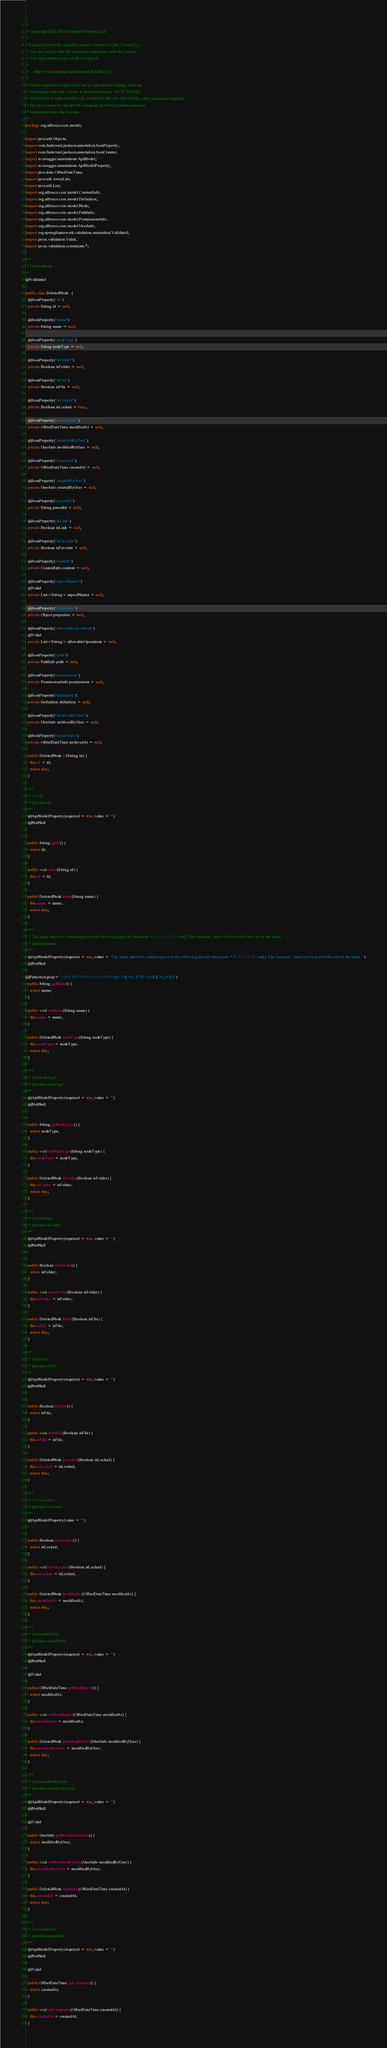<code> <loc_0><loc_0><loc_500><loc_500><_Java_>/*
 * Copyright 2021-2021 Alfresco Software, Ltd.
 *
 * Licensed under the Apache License, Version 2.0 (the "License");
 * you may not use this file except in compliance with the License.
 * You may obtain a copy of the License at
 *
 *     http://www.apache.org/licenses/LICENSE-2.0
 *
 * Unless required by applicable law or agreed to in writing, software
 * distributed under the License is distributed on an "AS IS" BASIS,
 * WITHOUT WARRANTIES OR CONDITIONS OF ANY KIND, either express or implied.
 * See the License for the specific language governing permissions and
 * limitations under the License.
 */
package org.alfresco.core.model;

import java.util.Objects;
import com.fasterxml.jackson.annotation.JsonProperty;
import com.fasterxml.jackson.annotation.JsonCreator;
import io.swagger.annotations.ApiModel;
import io.swagger.annotations.ApiModelProperty;
import java.time.OffsetDateTime;
import java.util.ArrayList;
import java.util.List;
import org.alfresco.core.model.ContentInfo;
import org.alfresco.core.model.Definition;
import org.alfresco.core.model.Node;
import org.alfresco.core.model.PathInfo;
import org.alfresco.core.model.PermissionsInfo;
import org.alfresco.core.model.UserInfo;
import org.springframework.validation.annotation.Validated;
import javax.validation.Valid;
import javax.validation.constraints.*;

/**
 * DeletedNode
 */
@Validated

public class DeletedNode   {
  @JsonProperty("id")
  private String id = null;

  @JsonProperty("name")
  private String name = null;

  @JsonProperty("nodeType")
  private String nodeType = null;

  @JsonProperty("isFolder")
  private Boolean isFolder = null;

  @JsonProperty("isFile")
  private Boolean isFile = null;

  @JsonProperty("isLocked")
  private Boolean isLocked = false;

  @JsonProperty("modifiedAt")
  private OffsetDateTime modifiedAt = null;

  @JsonProperty("modifiedByUser")
  private UserInfo modifiedByUser = null;

  @JsonProperty("createdAt")
  private OffsetDateTime createdAt = null;

  @JsonProperty("createdByUser")
  private UserInfo createdByUser = null;

  @JsonProperty("parentId")
  private String parentId = null;

  @JsonProperty("isLink")
  private Boolean isLink = null;

  @JsonProperty("isFavorite")
  private Boolean isFavorite = null;

  @JsonProperty("content")
  private ContentInfo content = null;

  @JsonProperty("aspectNames")
  @Valid
  private List<String> aspectNames = null;

  @JsonProperty("properties")
  private Object properties = null;

  @JsonProperty("allowableOperations")
  @Valid
  private List<String> allowableOperations = null;

  @JsonProperty("path")
  private PathInfo path = null;

  @JsonProperty("permissions")
  private PermissionsInfo permissions = null;

  @JsonProperty("definition")
  private Definition definition = null;

  @JsonProperty("archivedByUser")
  private UserInfo archivedByUser = null;

  @JsonProperty("archivedAt")
  private OffsetDateTime archivedAt = null;

  public DeletedNode id(String id) {
    this.id = id;
    return this;
  }

  /**
   * Get id
   * @return id
  **/
  @ApiModelProperty(required = true, value = "")
  @NotNull


  public String getId() {
    return id;
  }

  public void setId(String id) {
    this.id = id;
  }

  public DeletedNode name(String name) {
    this.name = name;
    return this;
  }

  /**
   * The name must not contain spaces or the following special characters: * \" < > \\ / ? : and |. The character . must not be used at the end of the name. 
   * @return name
  **/
  @ApiModelProperty(required = true, value = "The name must not contain spaces or the following special characters: * \" < > \\ / ? : and |. The character . must not be used at the end of the name. ")
  @NotNull

@Pattern(regexp="^(?!(.*[\\\"\\*\\\\\\>\\<\\?/\\:\\|]+.*)|(.*[\\.]?.*[\\.]+$)|(.*[ ]+$))") 
  public String getName() {
    return name;
  }

  public void setName(String name) {
    this.name = name;
  }

  public DeletedNode nodeType(String nodeType) {
    this.nodeType = nodeType;
    return this;
  }

  /**
   * Get nodeType
   * @return nodeType
  **/
  @ApiModelProperty(required = true, value = "")
  @NotNull


  public String getNodeType() {
    return nodeType;
  }

  public void setNodeType(String nodeType) {
    this.nodeType = nodeType;
  }

  public DeletedNode isFolder(Boolean isFolder) {
    this.isFolder = isFolder;
    return this;
  }

  /**
   * Get isFolder
   * @return isFolder
  **/
  @ApiModelProperty(required = true, value = "")
  @NotNull


  public Boolean isIsFolder() {
    return isFolder;
  }

  public void setIsFolder(Boolean isFolder) {
    this.isFolder = isFolder;
  }

  public DeletedNode isFile(Boolean isFile) {
    this.isFile = isFile;
    return this;
  }

  /**
   * Get isFile
   * @return isFile
  **/
  @ApiModelProperty(required = true, value = "")
  @NotNull


  public Boolean isIsFile() {
    return isFile;
  }

  public void setIsFile(Boolean isFile) {
    this.isFile = isFile;
  }

  public DeletedNode isLocked(Boolean isLocked) {
    this.isLocked = isLocked;
    return this;
  }

  /**
   * Get isLocked
   * @return isLocked
  **/
  @ApiModelProperty(value = "")


  public Boolean isIsLocked() {
    return isLocked;
  }

  public void setIsLocked(Boolean isLocked) {
    this.isLocked = isLocked;
  }

  public DeletedNode modifiedAt(OffsetDateTime modifiedAt) {
    this.modifiedAt = modifiedAt;
    return this;
  }

  /**
   * Get modifiedAt
   * @return modifiedAt
  **/
  @ApiModelProperty(required = true, value = "")
  @NotNull

  @Valid

  public OffsetDateTime getModifiedAt() {
    return modifiedAt;
  }

  public void setModifiedAt(OffsetDateTime modifiedAt) {
    this.modifiedAt = modifiedAt;
  }

  public DeletedNode modifiedByUser(UserInfo modifiedByUser) {
    this.modifiedByUser = modifiedByUser;
    return this;
  }

  /**
   * Get modifiedByUser
   * @return modifiedByUser
  **/
  @ApiModelProperty(required = true, value = "")
  @NotNull

  @Valid

  public UserInfo getModifiedByUser() {
    return modifiedByUser;
  }

  public void setModifiedByUser(UserInfo modifiedByUser) {
    this.modifiedByUser = modifiedByUser;
  }

  public DeletedNode createdAt(OffsetDateTime createdAt) {
    this.createdAt = createdAt;
    return this;
  }

  /**
   * Get createdAt
   * @return createdAt
  **/
  @ApiModelProperty(required = true, value = "")
  @NotNull

  @Valid

  public OffsetDateTime getCreatedAt() {
    return createdAt;
  }

  public void setCreatedAt(OffsetDateTime createdAt) {
    this.createdAt = createdAt;
  }
</code> 